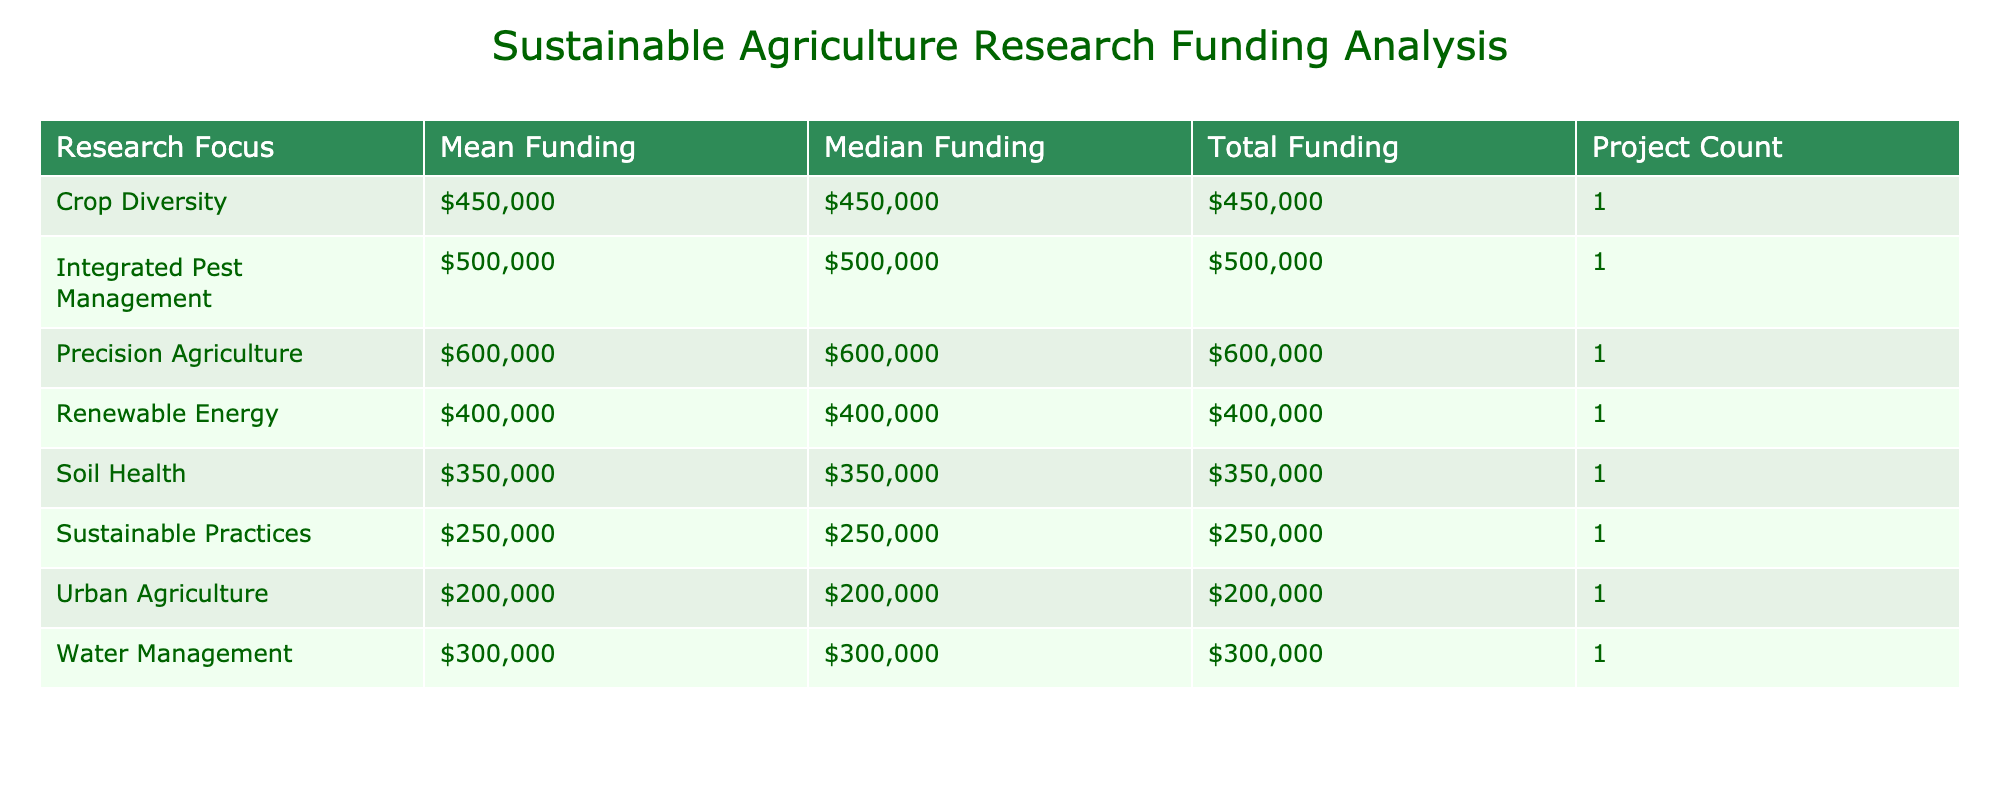What is the total funding allocated to research on Crop Diversity? The total funding for the Research Focus 'Crop Diversity' can be found in the 'Total Funding' column corresponding to that focus. By locating 'Crop Diversity' in the table, we see that the 'Total Funding' amount listed is $450,000.
Answer: $450,000 Which research project has the highest mean funding? To determine the research project with the highest mean funding, we look at the 'Mean Funding' values for each Research Focus. By scanning through the figures, we see that 'Precision Agriculture' has the highest mean funding of $600,000.
Answer: Precision Farming for Reduced Inputs How many projects are focused on Urban Agriculture? We need to check the 'Project Count' column and see how many projects fall under the 'Urban Agriculture' research focus. In this case, there is one project listed under this focus, which is 'Urban Farming Innovations.'
Answer: 1 What is the difference between the total funding for Soil Health and Precision Agriculture? First, we'll look at the 'Total Funding' amounts for 'Soil Health' and 'Precision Agriculture.' The total funding for Soil Health is $350,000 and for Precision Agriculture is $600,000. Now, we calculate the difference: $600,000 - $350,000 = $250,000.
Answer: $250,000 Is there any funding allocated to research in Kenya? Looking through the table for any mentions of projects focused on Kenya, we find one project under the 'Water Management' research focus. Therefore, the answer is yes, there is funding allocated for research in Kenya.
Answer: Yes What is the mean funding amount for the Renewable Energy focus? To find the mean funding amount for Renewable Energy, we look for this focus in the 'Mean Funding' column. The amount listed is $400,000 for the 'Renewable Energy' focus, giving us our answer.
Answer: $400,000 How does the median funding of Sustainable Practices compare to that of Water Management? We first check the 'Median Funding' values for both Research Focus categories. The 'Sustainable Practices' median funding is $250,000 while for 'Water Management' it is $300,000. We compare these and find that $250,000 is less than $300,000.
Answer: $250,000 is less than $300,000 What is the total number of research projects listed in the table? To find the total number of research projects, we add up the 'Project Count' values under each research focus. By observing the table, we see each focus has one project listed, leading to a total of eight projects.
Answer: 8 